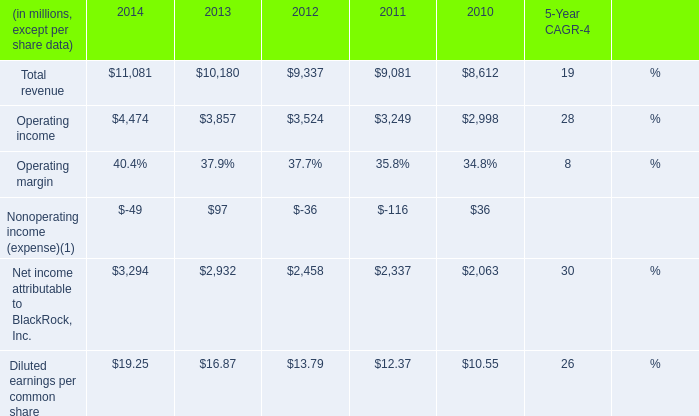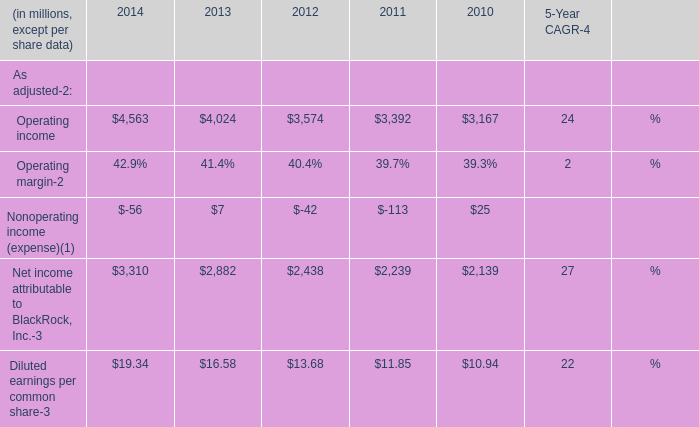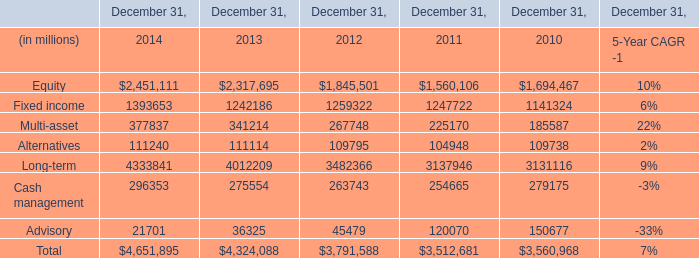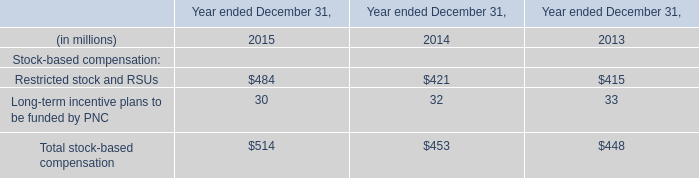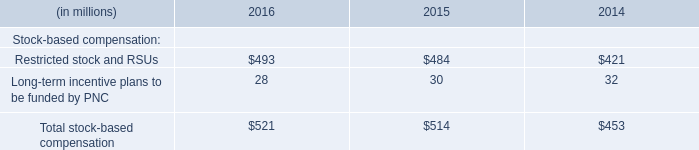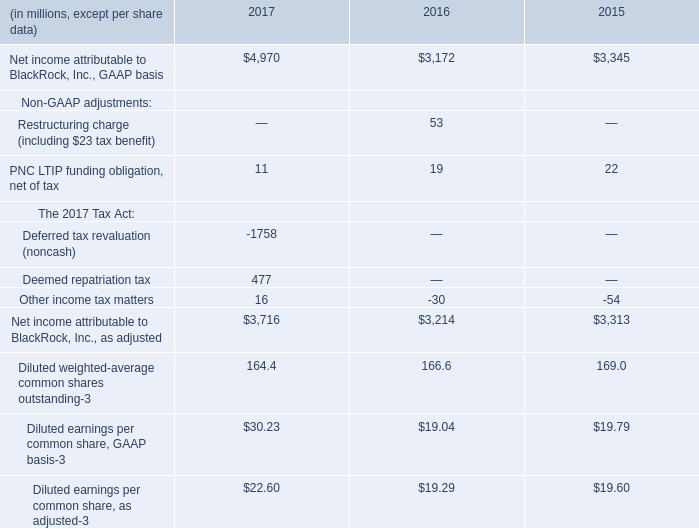What's the average of Equity and Fixed income in 2014? (in millions) 
Computations: ((2451111 + 1393653) / 2)
Answer: 1922382.0. 